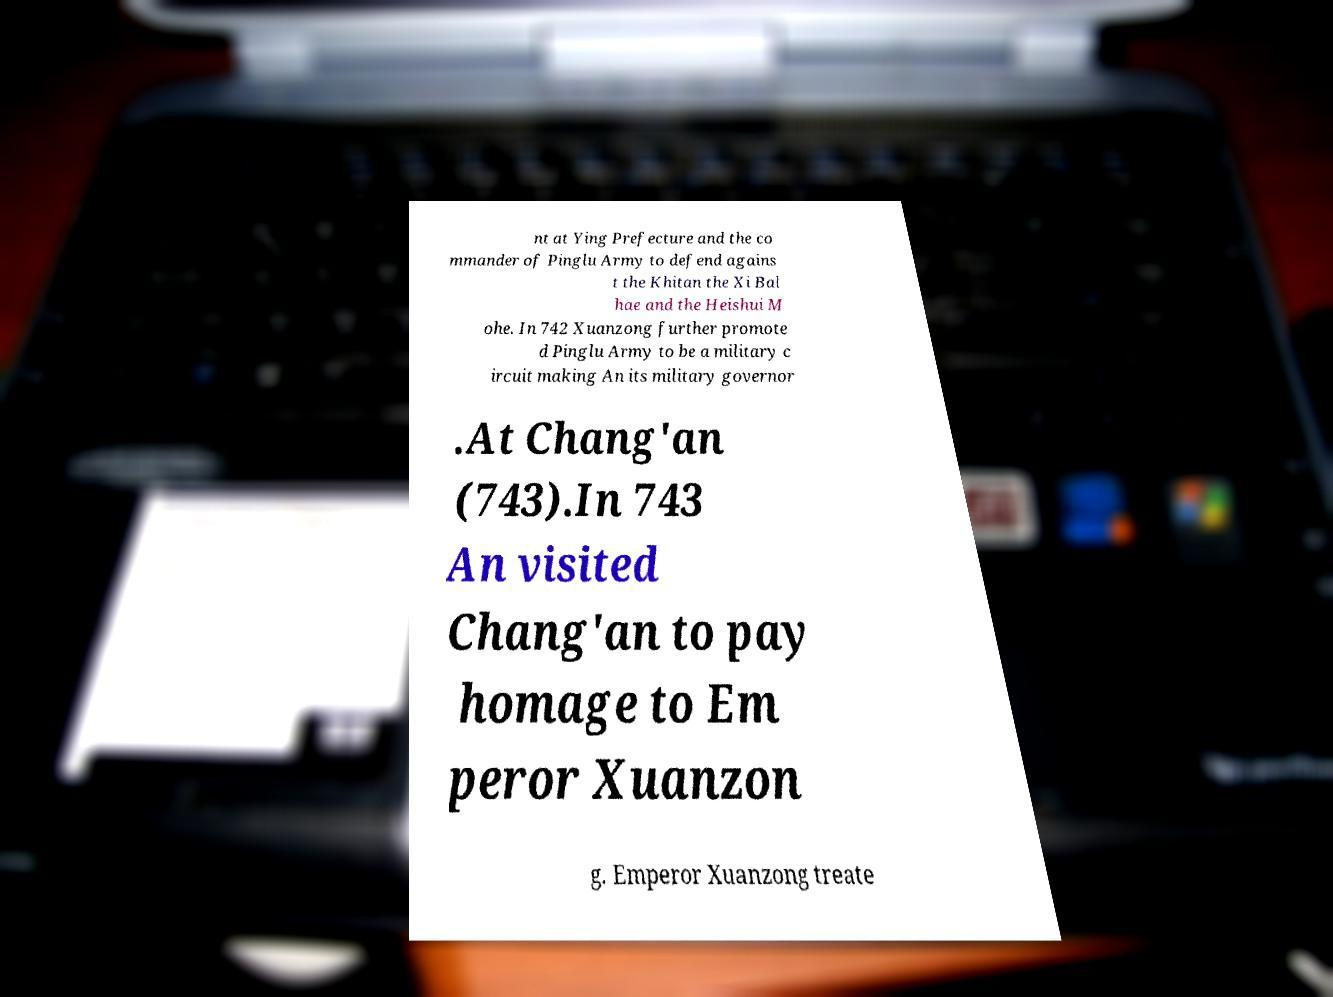Could you extract and type out the text from this image? nt at Ying Prefecture and the co mmander of Pinglu Army to defend agains t the Khitan the Xi Bal hae and the Heishui M ohe. In 742 Xuanzong further promote d Pinglu Army to be a military c ircuit making An its military governor .At Chang'an (743).In 743 An visited Chang'an to pay homage to Em peror Xuanzon g. Emperor Xuanzong treate 